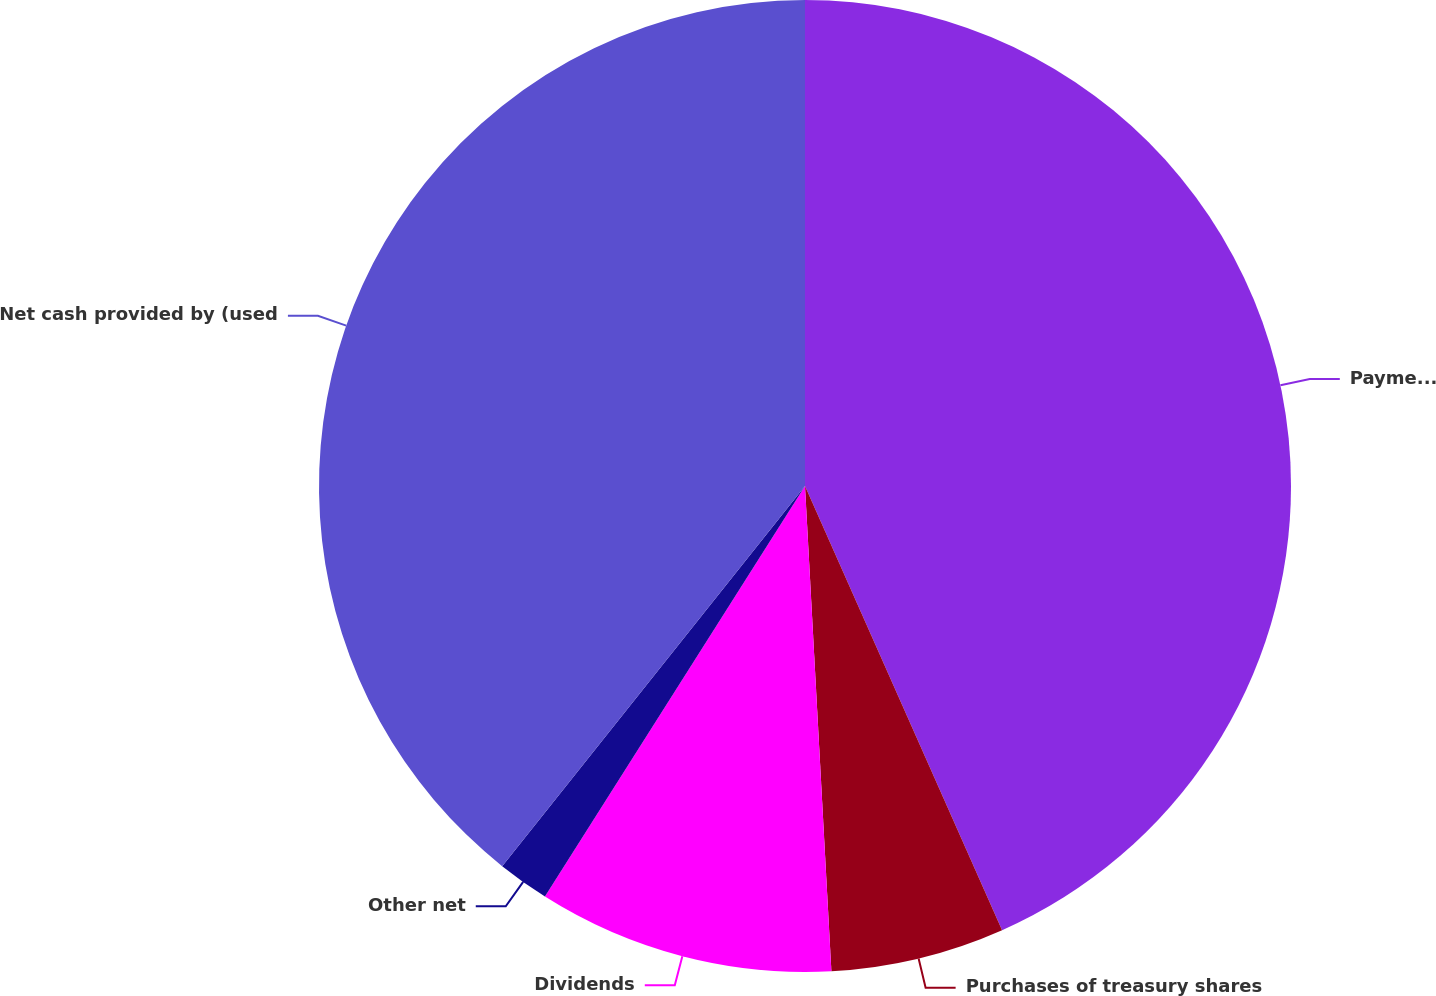<chart> <loc_0><loc_0><loc_500><loc_500><pie_chart><fcel>Payments on debt<fcel>Purchases of treasury shares<fcel>Dividends<fcel>Other net<fcel>Net cash provided by (used<nl><fcel>43.35%<fcel>5.78%<fcel>9.85%<fcel>1.72%<fcel>39.29%<nl></chart> 